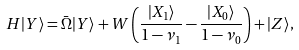Convert formula to latex. <formula><loc_0><loc_0><loc_500><loc_500>H | Y \rangle = \bar { \Omega } | Y \rangle + W \left ( \frac { | X _ { 1 } \rangle } { 1 - \nu _ { 1 } } - \frac { | X _ { 0 } \rangle } { 1 - \nu _ { 0 } } \right ) + | Z \rangle ,</formula> 